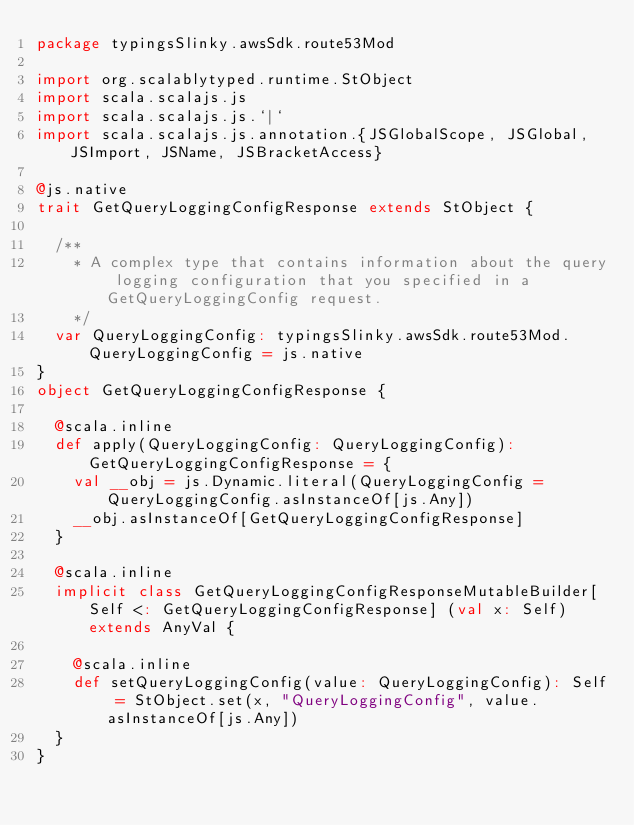<code> <loc_0><loc_0><loc_500><loc_500><_Scala_>package typingsSlinky.awsSdk.route53Mod

import org.scalablytyped.runtime.StObject
import scala.scalajs.js
import scala.scalajs.js.`|`
import scala.scalajs.js.annotation.{JSGlobalScope, JSGlobal, JSImport, JSName, JSBracketAccess}

@js.native
trait GetQueryLoggingConfigResponse extends StObject {
  
  /**
    * A complex type that contains information about the query logging configuration that you specified in a GetQueryLoggingConfig request.
    */
  var QueryLoggingConfig: typingsSlinky.awsSdk.route53Mod.QueryLoggingConfig = js.native
}
object GetQueryLoggingConfigResponse {
  
  @scala.inline
  def apply(QueryLoggingConfig: QueryLoggingConfig): GetQueryLoggingConfigResponse = {
    val __obj = js.Dynamic.literal(QueryLoggingConfig = QueryLoggingConfig.asInstanceOf[js.Any])
    __obj.asInstanceOf[GetQueryLoggingConfigResponse]
  }
  
  @scala.inline
  implicit class GetQueryLoggingConfigResponseMutableBuilder[Self <: GetQueryLoggingConfigResponse] (val x: Self) extends AnyVal {
    
    @scala.inline
    def setQueryLoggingConfig(value: QueryLoggingConfig): Self = StObject.set(x, "QueryLoggingConfig", value.asInstanceOf[js.Any])
  }
}
</code> 